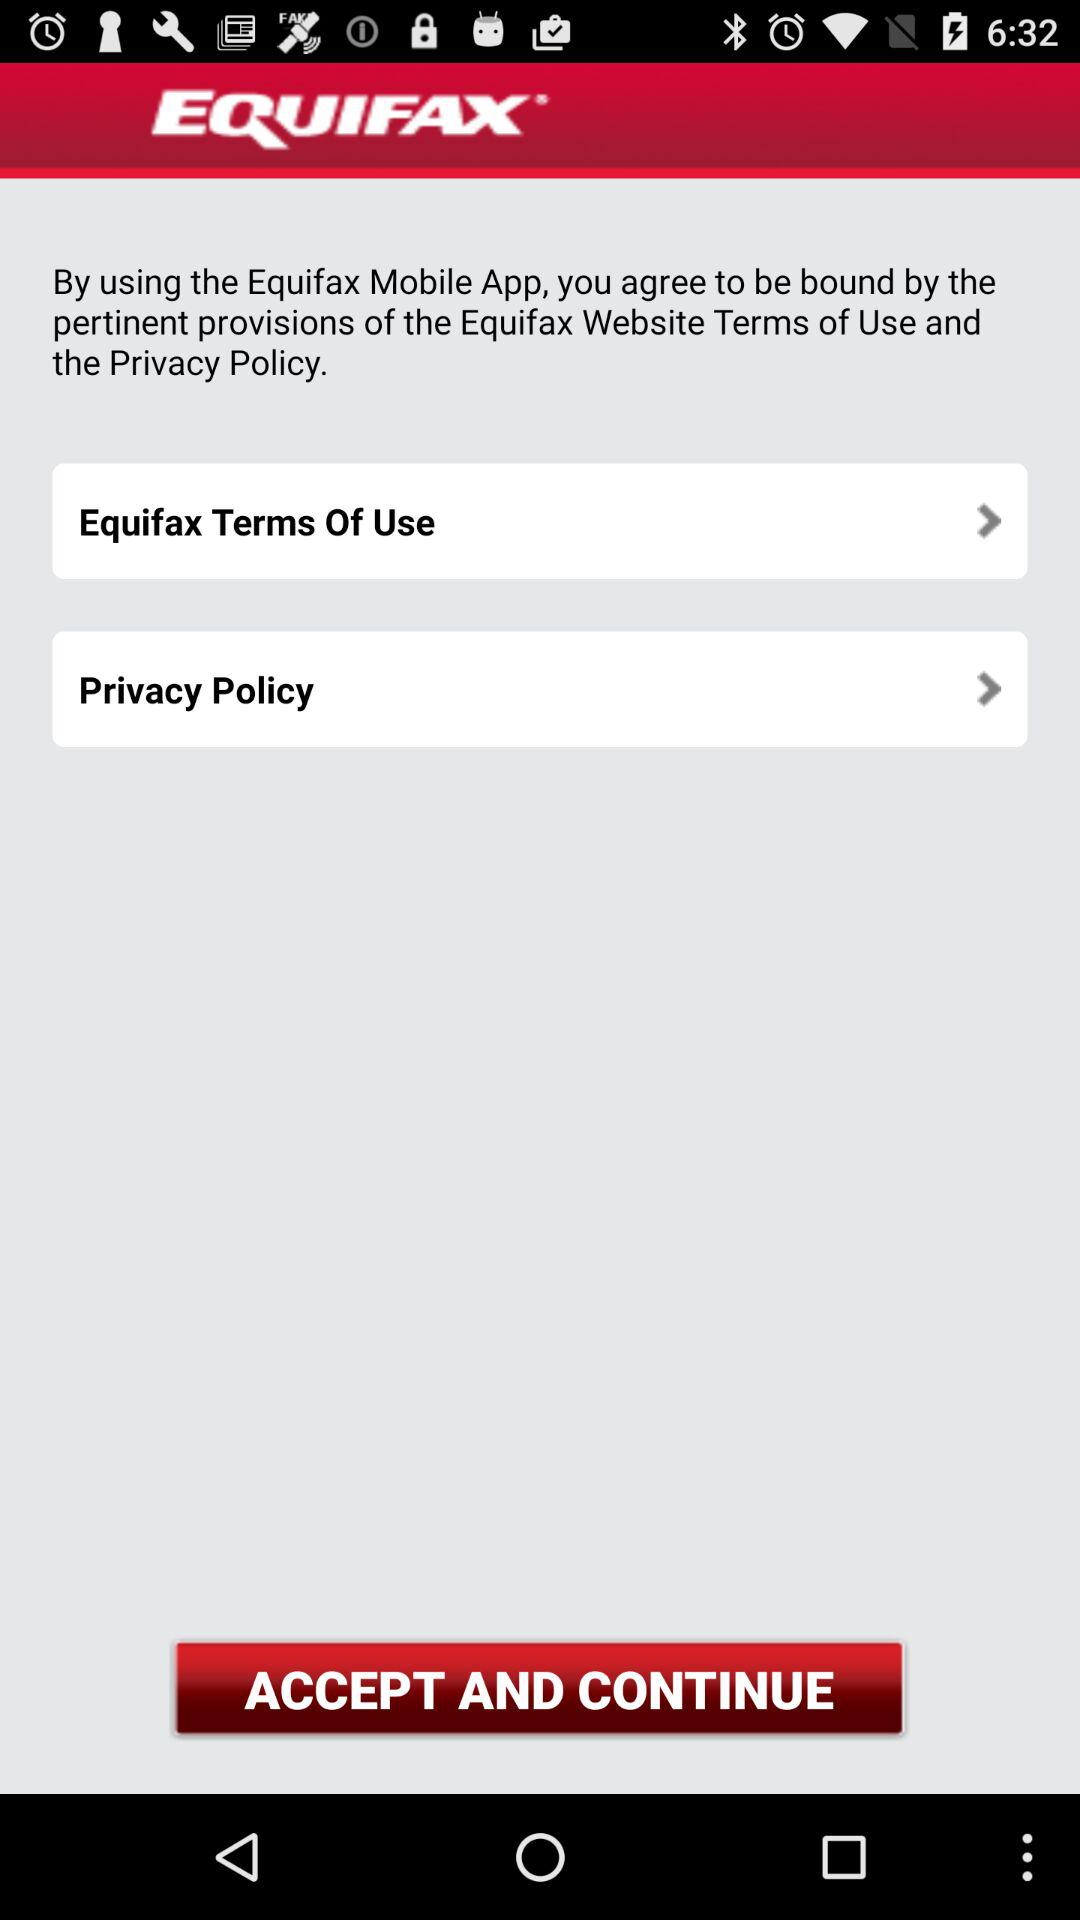What is the application name? The application name is "EQUIFAX". 